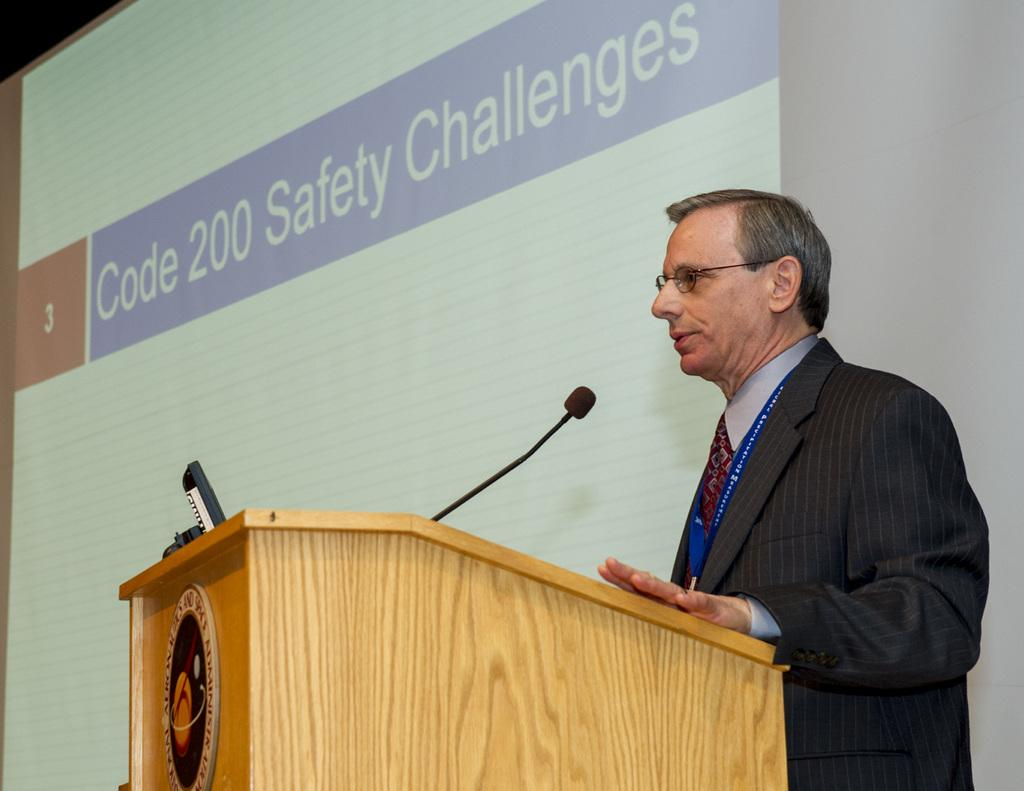What is the main subject of the image? There is a person standing in the image. What object is visible near the person? There is a microphone in the image. What is located on the podium in the image? There are objects on a podium in the image. What can be seen in the background of the image? There is a screen in the background of the image. What type of sand can be seen on the person's skin in the image? There is no sand visible on the person's skin in the image. What type of flesh is visible on the person's face in the image? The person's face is not described in detail, so we cannot determine the type of flesh visible. What town is depicted in the background of the image? There is no town visible in the image; only a screen is present in the background. 